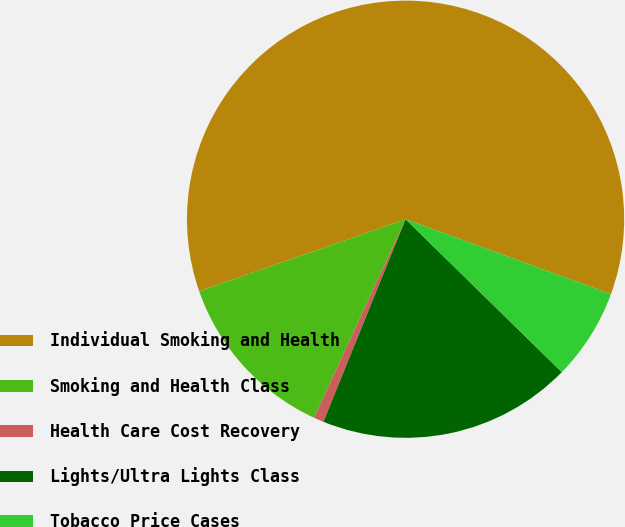<chart> <loc_0><loc_0><loc_500><loc_500><pie_chart><fcel>Individual Smoking and Health<fcel>Smoking and Health Class<fcel>Health Care Cost Recovery<fcel>Lights/Ultra Lights Class<fcel>Tobacco Price Cases<nl><fcel>60.92%<fcel>12.78%<fcel>0.74%<fcel>18.8%<fcel>6.76%<nl></chart> 